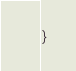<code> <loc_0><loc_0><loc_500><loc_500><_Kotlin_>}
</code> 